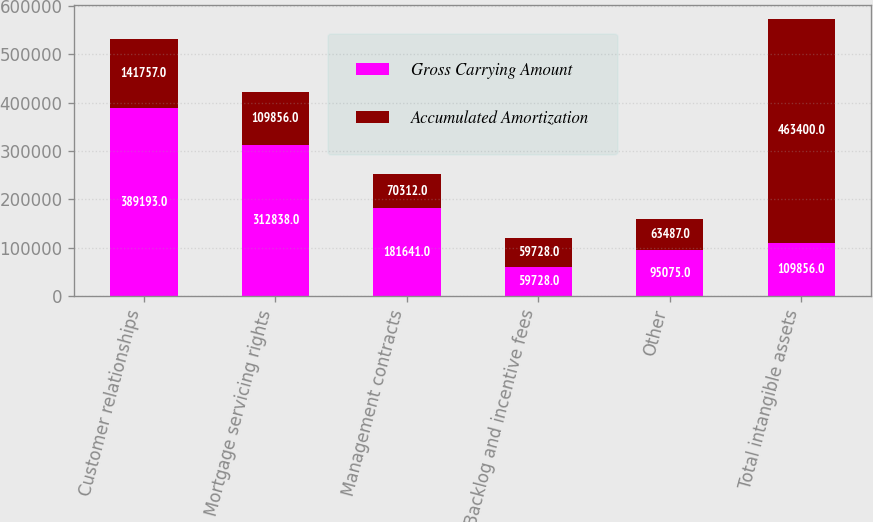<chart> <loc_0><loc_0><loc_500><loc_500><stacked_bar_chart><ecel><fcel>Customer relationships<fcel>Mortgage servicing rights<fcel>Management contracts<fcel>Backlog and incentive fees<fcel>Other<fcel>Total intangible assets<nl><fcel>Gross Carrying Amount<fcel>389193<fcel>312838<fcel>181641<fcel>59728<fcel>95075<fcel>109856<nl><fcel>Accumulated Amortization<fcel>141757<fcel>109856<fcel>70312<fcel>59728<fcel>63487<fcel>463400<nl></chart> 